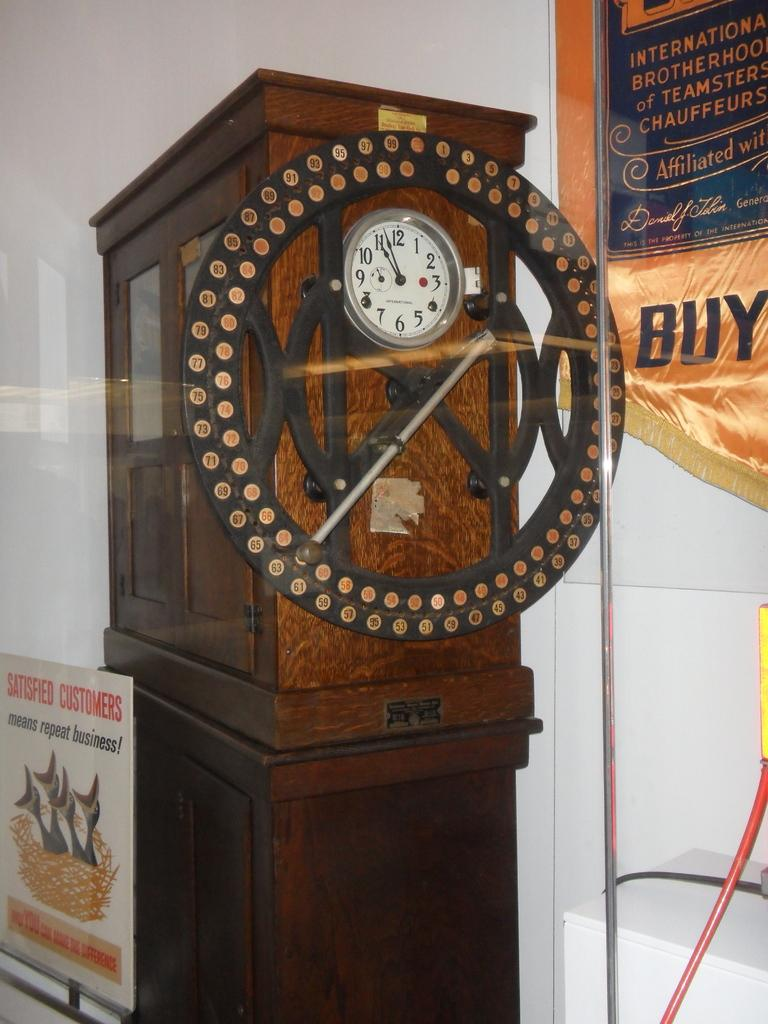<image>
Give a short and clear explanation of the subsequent image. A signboard states that Satisfied Customers means repeat business. 